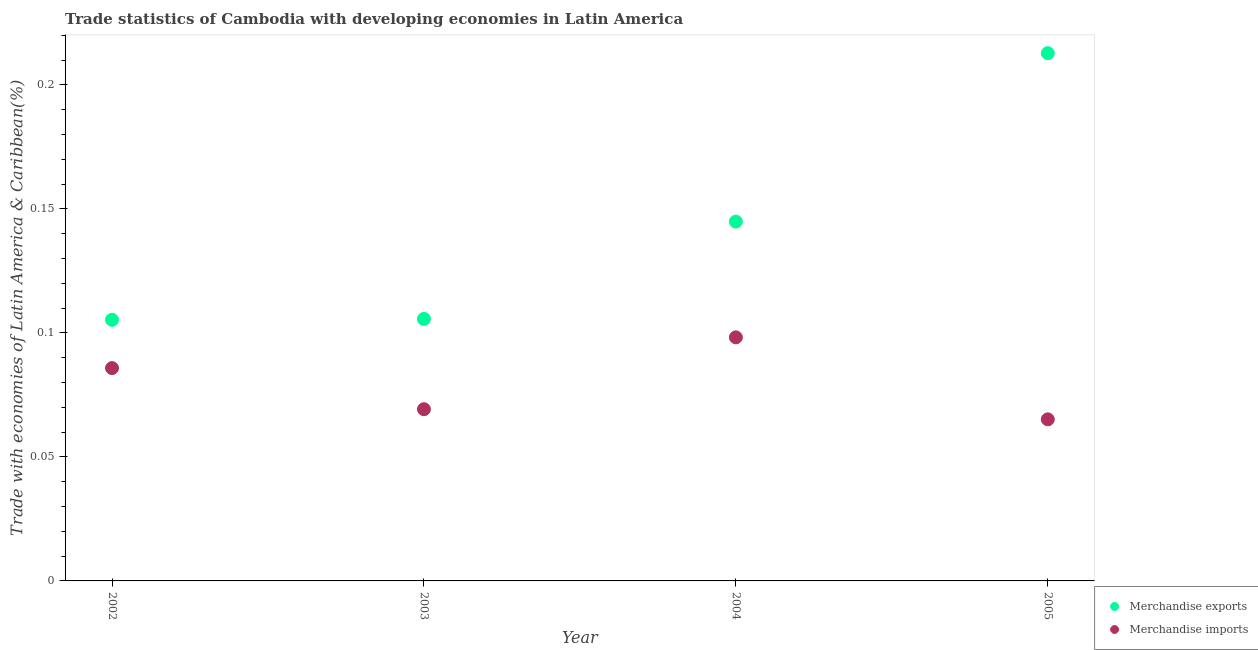How many different coloured dotlines are there?
Make the answer very short. 2. What is the merchandise exports in 2004?
Make the answer very short. 0.14. Across all years, what is the maximum merchandise imports?
Your response must be concise. 0.1. Across all years, what is the minimum merchandise imports?
Ensure brevity in your answer.  0.07. In which year was the merchandise exports maximum?
Offer a very short reply. 2005. In which year was the merchandise exports minimum?
Make the answer very short. 2002. What is the total merchandise exports in the graph?
Keep it short and to the point. 0.57. What is the difference between the merchandise imports in 2003 and that in 2004?
Keep it short and to the point. -0.03. What is the difference between the merchandise imports in 2002 and the merchandise exports in 2004?
Your response must be concise. -0.06. What is the average merchandise exports per year?
Offer a terse response. 0.14. In the year 2002, what is the difference between the merchandise imports and merchandise exports?
Provide a short and direct response. -0.02. What is the ratio of the merchandise imports in 2003 to that in 2005?
Make the answer very short. 1.06. Is the merchandise exports in 2004 less than that in 2005?
Give a very brief answer. Yes. Is the difference between the merchandise exports in 2004 and 2005 greater than the difference between the merchandise imports in 2004 and 2005?
Keep it short and to the point. No. What is the difference between the highest and the second highest merchandise imports?
Give a very brief answer. 0.01. What is the difference between the highest and the lowest merchandise imports?
Your response must be concise. 0.03. In how many years, is the merchandise exports greater than the average merchandise exports taken over all years?
Your answer should be compact. 2. Is the sum of the merchandise exports in 2004 and 2005 greater than the maximum merchandise imports across all years?
Provide a succinct answer. Yes. Does the merchandise imports monotonically increase over the years?
Your answer should be compact. No. Is the merchandise imports strictly less than the merchandise exports over the years?
Your answer should be compact. Yes. How many dotlines are there?
Provide a succinct answer. 2. Are the values on the major ticks of Y-axis written in scientific E-notation?
Give a very brief answer. No. Does the graph contain any zero values?
Ensure brevity in your answer.  No. Does the graph contain grids?
Your answer should be very brief. No. Where does the legend appear in the graph?
Offer a very short reply. Bottom right. How many legend labels are there?
Your answer should be very brief. 2. What is the title of the graph?
Provide a short and direct response. Trade statistics of Cambodia with developing economies in Latin America. What is the label or title of the Y-axis?
Make the answer very short. Trade with economies of Latin America & Caribbean(%). What is the Trade with economies of Latin America & Caribbean(%) in Merchandise exports in 2002?
Ensure brevity in your answer.  0.11. What is the Trade with economies of Latin America & Caribbean(%) in Merchandise imports in 2002?
Give a very brief answer. 0.09. What is the Trade with economies of Latin America & Caribbean(%) of Merchandise exports in 2003?
Offer a very short reply. 0.11. What is the Trade with economies of Latin America & Caribbean(%) in Merchandise imports in 2003?
Make the answer very short. 0.07. What is the Trade with economies of Latin America & Caribbean(%) in Merchandise exports in 2004?
Provide a succinct answer. 0.14. What is the Trade with economies of Latin America & Caribbean(%) of Merchandise imports in 2004?
Offer a terse response. 0.1. What is the Trade with economies of Latin America & Caribbean(%) in Merchandise exports in 2005?
Ensure brevity in your answer.  0.21. What is the Trade with economies of Latin America & Caribbean(%) of Merchandise imports in 2005?
Provide a short and direct response. 0.07. Across all years, what is the maximum Trade with economies of Latin America & Caribbean(%) of Merchandise exports?
Your response must be concise. 0.21. Across all years, what is the maximum Trade with economies of Latin America & Caribbean(%) in Merchandise imports?
Your response must be concise. 0.1. Across all years, what is the minimum Trade with economies of Latin America & Caribbean(%) of Merchandise exports?
Your response must be concise. 0.11. Across all years, what is the minimum Trade with economies of Latin America & Caribbean(%) of Merchandise imports?
Make the answer very short. 0.07. What is the total Trade with economies of Latin America & Caribbean(%) of Merchandise exports in the graph?
Your answer should be compact. 0.57. What is the total Trade with economies of Latin America & Caribbean(%) of Merchandise imports in the graph?
Give a very brief answer. 0.32. What is the difference between the Trade with economies of Latin America & Caribbean(%) in Merchandise exports in 2002 and that in 2003?
Your answer should be very brief. -0. What is the difference between the Trade with economies of Latin America & Caribbean(%) in Merchandise imports in 2002 and that in 2003?
Provide a short and direct response. 0.02. What is the difference between the Trade with economies of Latin America & Caribbean(%) of Merchandise exports in 2002 and that in 2004?
Ensure brevity in your answer.  -0.04. What is the difference between the Trade with economies of Latin America & Caribbean(%) in Merchandise imports in 2002 and that in 2004?
Your response must be concise. -0.01. What is the difference between the Trade with economies of Latin America & Caribbean(%) in Merchandise exports in 2002 and that in 2005?
Make the answer very short. -0.11. What is the difference between the Trade with economies of Latin America & Caribbean(%) of Merchandise imports in 2002 and that in 2005?
Your answer should be very brief. 0.02. What is the difference between the Trade with economies of Latin America & Caribbean(%) in Merchandise exports in 2003 and that in 2004?
Ensure brevity in your answer.  -0.04. What is the difference between the Trade with economies of Latin America & Caribbean(%) in Merchandise imports in 2003 and that in 2004?
Make the answer very short. -0.03. What is the difference between the Trade with economies of Latin America & Caribbean(%) of Merchandise exports in 2003 and that in 2005?
Provide a short and direct response. -0.11. What is the difference between the Trade with economies of Latin America & Caribbean(%) in Merchandise imports in 2003 and that in 2005?
Ensure brevity in your answer.  0. What is the difference between the Trade with economies of Latin America & Caribbean(%) in Merchandise exports in 2004 and that in 2005?
Your answer should be compact. -0.07. What is the difference between the Trade with economies of Latin America & Caribbean(%) of Merchandise imports in 2004 and that in 2005?
Provide a succinct answer. 0.03. What is the difference between the Trade with economies of Latin America & Caribbean(%) in Merchandise exports in 2002 and the Trade with economies of Latin America & Caribbean(%) in Merchandise imports in 2003?
Make the answer very short. 0.04. What is the difference between the Trade with economies of Latin America & Caribbean(%) of Merchandise exports in 2002 and the Trade with economies of Latin America & Caribbean(%) of Merchandise imports in 2004?
Ensure brevity in your answer.  0.01. What is the difference between the Trade with economies of Latin America & Caribbean(%) in Merchandise exports in 2002 and the Trade with economies of Latin America & Caribbean(%) in Merchandise imports in 2005?
Your answer should be very brief. 0.04. What is the difference between the Trade with economies of Latin America & Caribbean(%) of Merchandise exports in 2003 and the Trade with economies of Latin America & Caribbean(%) of Merchandise imports in 2004?
Your answer should be very brief. 0.01. What is the difference between the Trade with economies of Latin America & Caribbean(%) of Merchandise exports in 2003 and the Trade with economies of Latin America & Caribbean(%) of Merchandise imports in 2005?
Make the answer very short. 0.04. What is the difference between the Trade with economies of Latin America & Caribbean(%) of Merchandise exports in 2004 and the Trade with economies of Latin America & Caribbean(%) of Merchandise imports in 2005?
Provide a short and direct response. 0.08. What is the average Trade with economies of Latin America & Caribbean(%) of Merchandise exports per year?
Provide a succinct answer. 0.14. What is the average Trade with economies of Latin America & Caribbean(%) of Merchandise imports per year?
Your response must be concise. 0.08. In the year 2002, what is the difference between the Trade with economies of Latin America & Caribbean(%) of Merchandise exports and Trade with economies of Latin America & Caribbean(%) of Merchandise imports?
Keep it short and to the point. 0.02. In the year 2003, what is the difference between the Trade with economies of Latin America & Caribbean(%) in Merchandise exports and Trade with economies of Latin America & Caribbean(%) in Merchandise imports?
Offer a very short reply. 0.04. In the year 2004, what is the difference between the Trade with economies of Latin America & Caribbean(%) in Merchandise exports and Trade with economies of Latin America & Caribbean(%) in Merchandise imports?
Provide a short and direct response. 0.05. In the year 2005, what is the difference between the Trade with economies of Latin America & Caribbean(%) of Merchandise exports and Trade with economies of Latin America & Caribbean(%) of Merchandise imports?
Ensure brevity in your answer.  0.15. What is the ratio of the Trade with economies of Latin America & Caribbean(%) of Merchandise imports in 2002 to that in 2003?
Give a very brief answer. 1.24. What is the ratio of the Trade with economies of Latin America & Caribbean(%) of Merchandise exports in 2002 to that in 2004?
Keep it short and to the point. 0.73. What is the ratio of the Trade with economies of Latin America & Caribbean(%) of Merchandise imports in 2002 to that in 2004?
Offer a terse response. 0.87. What is the ratio of the Trade with economies of Latin America & Caribbean(%) of Merchandise exports in 2002 to that in 2005?
Your answer should be compact. 0.49. What is the ratio of the Trade with economies of Latin America & Caribbean(%) in Merchandise imports in 2002 to that in 2005?
Keep it short and to the point. 1.32. What is the ratio of the Trade with economies of Latin America & Caribbean(%) of Merchandise exports in 2003 to that in 2004?
Provide a short and direct response. 0.73. What is the ratio of the Trade with economies of Latin America & Caribbean(%) in Merchandise imports in 2003 to that in 2004?
Ensure brevity in your answer.  0.71. What is the ratio of the Trade with economies of Latin America & Caribbean(%) of Merchandise exports in 2003 to that in 2005?
Your response must be concise. 0.5. What is the ratio of the Trade with economies of Latin America & Caribbean(%) of Merchandise imports in 2003 to that in 2005?
Provide a short and direct response. 1.06. What is the ratio of the Trade with economies of Latin America & Caribbean(%) of Merchandise exports in 2004 to that in 2005?
Provide a succinct answer. 0.68. What is the ratio of the Trade with economies of Latin America & Caribbean(%) in Merchandise imports in 2004 to that in 2005?
Ensure brevity in your answer.  1.51. What is the difference between the highest and the second highest Trade with economies of Latin America & Caribbean(%) of Merchandise exports?
Give a very brief answer. 0.07. What is the difference between the highest and the second highest Trade with economies of Latin America & Caribbean(%) in Merchandise imports?
Give a very brief answer. 0.01. What is the difference between the highest and the lowest Trade with economies of Latin America & Caribbean(%) in Merchandise exports?
Provide a short and direct response. 0.11. What is the difference between the highest and the lowest Trade with economies of Latin America & Caribbean(%) in Merchandise imports?
Make the answer very short. 0.03. 